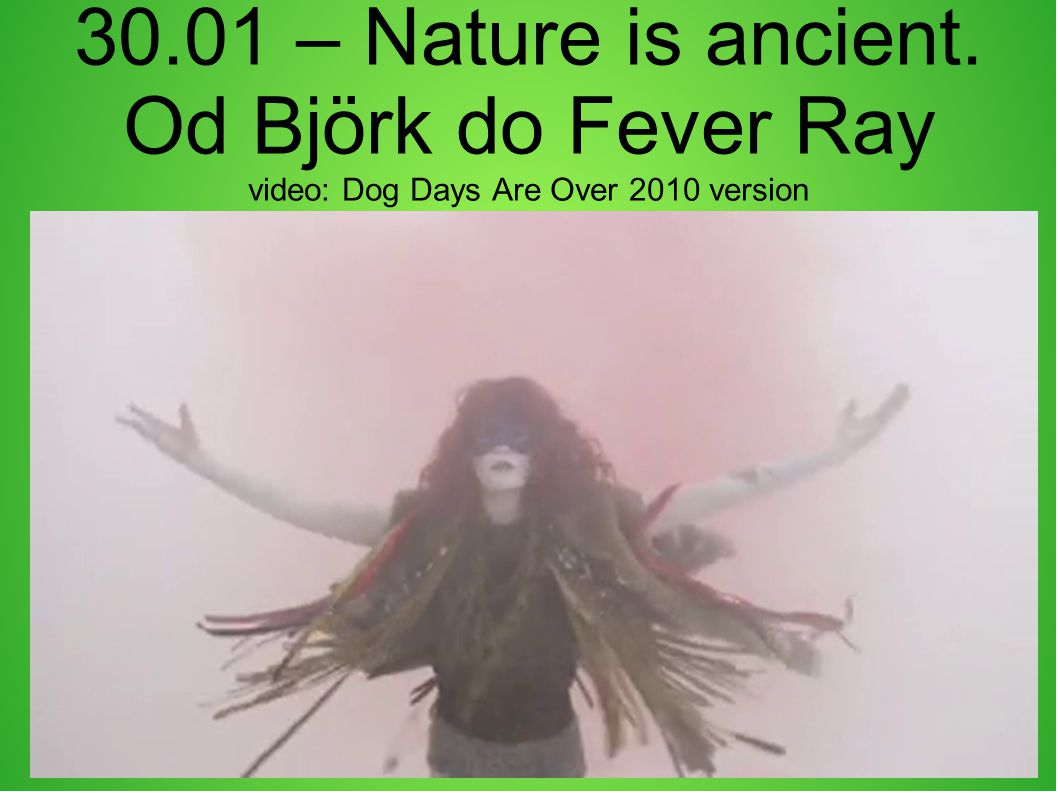What is the significance of the heavy smoke or fog surrounding the figure? The heavy smoke or fog surrounding the figure adds to the surreal and ethereal quality of the image. It creates an atmosphere of mystery and otherworldliness, enhancing the artistic expression. The obscured surroundings may symbolize ambiguity, emotions, or a dream-like state, aligning with the artistic intent of the video. 